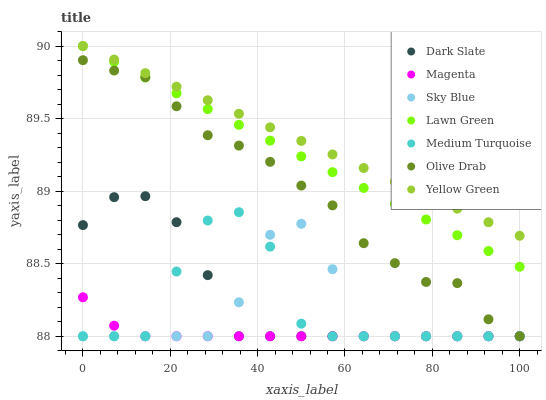Does Magenta have the minimum area under the curve?
Answer yes or no. Yes. Does Yellow Green have the maximum area under the curve?
Answer yes or no. Yes. Does Dark Slate have the minimum area under the curve?
Answer yes or no. No. Does Dark Slate have the maximum area under the curve?
Answer yes or no. No. Is Yellow Green the smoothest?
Answer yes or no. Yes. Is Medium Turquoise the roughest?
Answer yes or no. Yes. Is Dark Slate the smoothest?
Answer yes or no. No. Is Dark Slate the roughest?
Answer yes or no. No. Does Dark Slate have the lowest value?
Answer yes or no. Yes. Does Yellow Green have the lowest value?
Answer yes or no. No. Does Yellow Green have the highest value?
Answer yes or no. Yes. Does Dark Slate have the highest value?
Answer yes or no. No. Is Sky Blue less than Yellow Green?
Answer yes or no. Yes. Is Lawn Green greater than Sky Blue?
Answer yes or no. Yes. Does Sky Blue intersect Dark Slate?
Answer yes or no. Yes. Is Sky Blue less than Dark Slate?
Answer yes or no. No. Is Sky Blue greater than Dark Slate?
Answer yes or no. No. Does Sky Blue intersect Yellow Green?
Answer yes or no. No. 